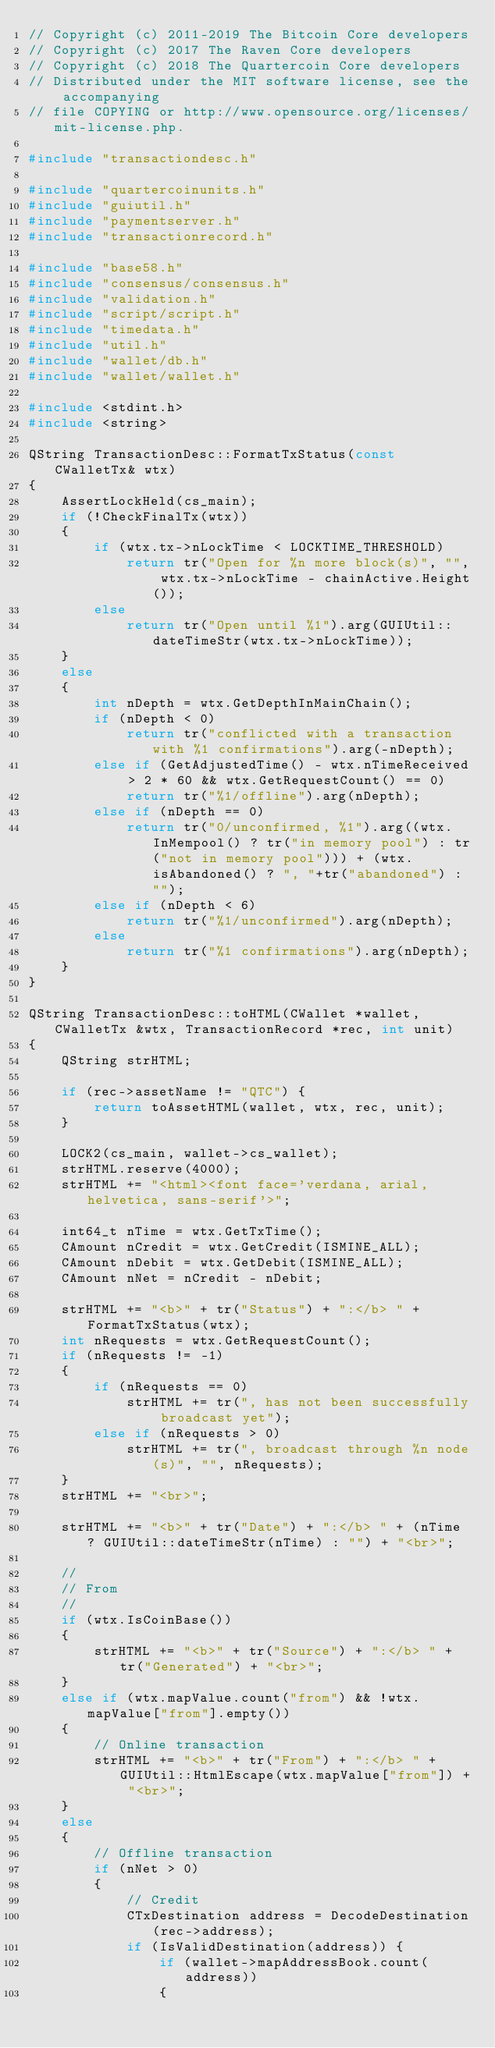Convert code to text. <code><loc_0><loc_0><loc_500><loc_500><_C++_>// Copyright (c) 2011-2019 The Bitcoin Core developers
// Copyright (c) 2017 The Raven Core developers
// Copyright (c) 2018 The Quartercoin Core developers
// Distributed under the MIT software license, see the accompanying
// file COPYING or http://www.opensource.org/licenses/mit-license.php.

#include "transactiondesc.h"

#include "quartercoinunits.h"
#include "guiutil.h"
#include "paymentserver.h"
#include "transactionrecord.h"

#include "base58.h"
#include "consensus/consensus.h"
#include "validation.h"
#include "script/script.h"
#include "timedata.h"
#include "util.h"
#include "wallet/db.h"
#include "wallet/wallet.h"

#include <stdint.h>
#include <string>

QString TransactionDesc::FormatTxStatus(const CWalletTx& wtx)
{
    AssertLockHeld(cs_main);
    if (!CheckFinalTx(wtx))
    {
        if (wtx.tx->nLockTime < LOCKTIME_THRESHOLD)
            return tr("Open for %n more block(s)", "", wtx.tx->nLockTime - chainActive.Height());
        else
            return tr("Open until %1").arg(GUIUtil::dateTimeStr(wtx.tx->nLockTime));
    }
    else
    {
        int nDepth = wtx.GetDepthInMainChain();
        if (nDepth < 0)
            return tr("conflicted with a transaction with %1 confirmations").arg(-nDepth);
        else if (GetAdjustedTime() - wtx.nTimeReceived > 2 * 60 && wtx.GetRequestCount() == 0)
            return tr("%1/offline").arg(nDepth);
        else if (nDepth == 0)
            return tr("0/unconfirmed, %1").arg((wtx.InMempool() ? tr("in memory pool") : tr("not in memory pool"))) + (wtx.isAbandoned() ? ", "+tr("abandoned") : "");
        else if (nDepth < 6)
            return tr("%1/unconfirmed").arg(nDepth);
        else
            return tr("%1 confirmations").arg(nDepth);
    }
}

QString TransactionDesc::toHTML(CWallet *wallet, CWalletTx &wtx, TransactionRecord *rec, int unit)
{
    QString strHTML;

    if (rec->assetName != "QTC") {
        return toAssetHTML(wallet, wtx, rec, unit);
    }

    LOCK2(cs_main, wallet->cs_wallet);
    strHTML.reserve(4000);
    strHTML += "<html><font face='verdana, arial, helvetica, sans-serif'>";

    int64_t nTime = wtx.GetTxTime();
    CAmount nCredit = wtx.GetCredit(ISMINE_ALL);
    CAmount nDebit = wtx.GetDebit(ISMINE_ALL);
    CAmount nNet = nCredit - nDebit;

    strHTML += "<b>" + tr("Status") + ":</b> " + FormatTxStatus(wtx);
    int nRequests = wtx.GetRequestCount();
    if (nRequests != -1)
    {
        if (nRequests == 0)
            strHTML += tr(", has not been successfully broadcast yet");
        else if (nRequests > 0)
            strHTML += tr(", broadcast through %n node(s)", "", nRequests);
    }
    strHTML += "<br>";

    strHTML += "<b>" + tr("Date") + ":</b> " + (nTime ? GUIUtil::dateTimeStr(nTime) : "") + "<br>";

    //
    // From
    //
    if (wtx.IsCoinBase())
    {
        strHTML += "<b>" + tr("Source") + ":</b> " + tr("Generated") + "<br>";
    }
    else if (wtx.mapValue.count("from") && !wtx.mapValue["from"].empty())
    {
        // Online transaction
        strHTML += "<b>" + tr("From") + ":</b> " + GUIUtil::HtmlEscape(wtx.mapValue["from"]) + "<br>";
    }
    else
    {
        // Offline transaction
        if (nNet > 0)
        {
            // Credit
            CTxDestination address = DecodeDestination(rec->address);
            if (IsValidDestination(address)) {
                if (wallet->mapAddressBook.count(address))
                {</code> 